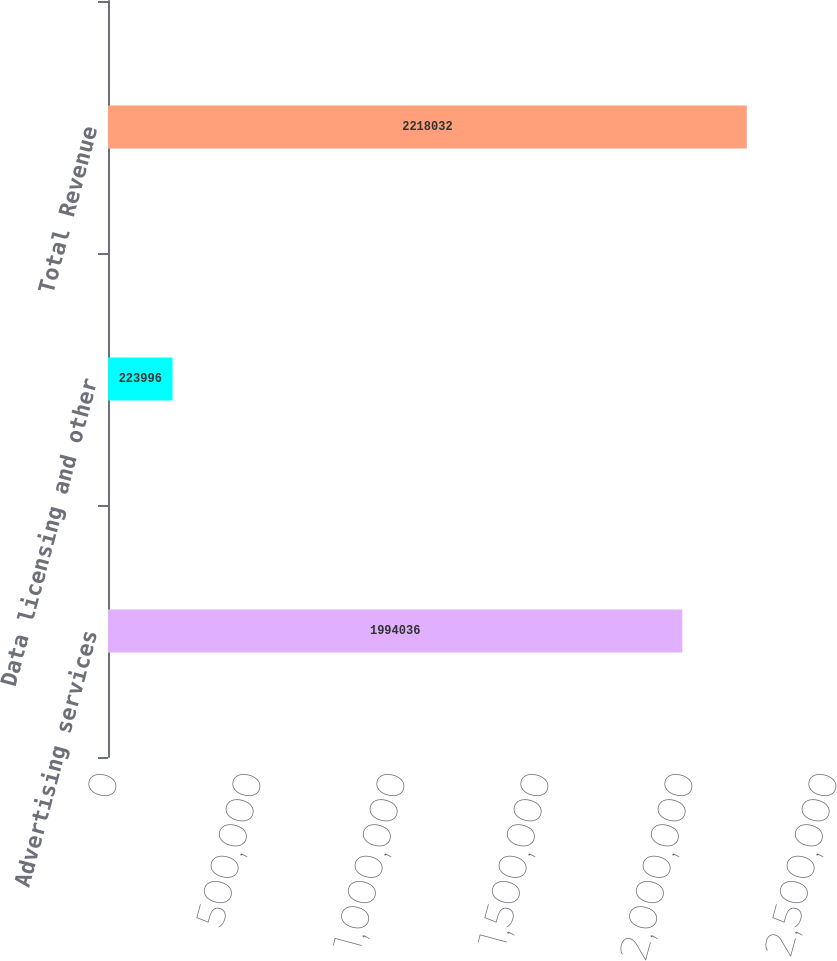Convert chart to OTSL. <chart><loc_0><loc_0><loc_500><loc_500><bar_chart><fcel>Advertising services<fcel>Data licensing and other<fcel>Total Revenue<nl><fcel>1.99404e+06<fcel>223996<fcel>2.21803e+06<nl></chart> 